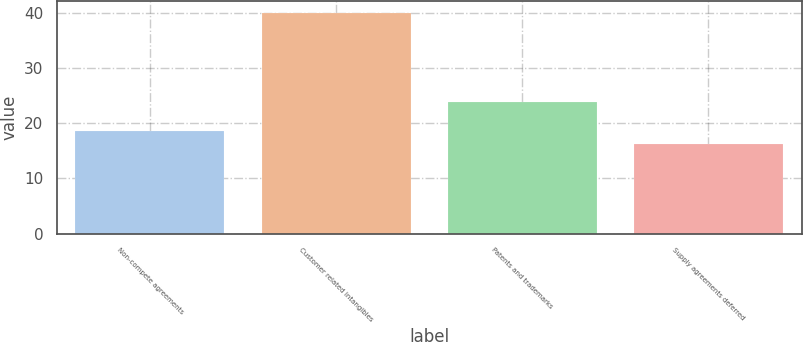<chart> <loc_0><loc_0><loc_500><loc_500><bar_chart><fcel>Non-compete agreements<fcel>Customer related intangibles<fcel>Patents and trademarks<fcel>Supply agreements deferred<nl><fcel>18.59<fcel>40.1<fcel>23.9<fcel>16.2<nl></chart> 